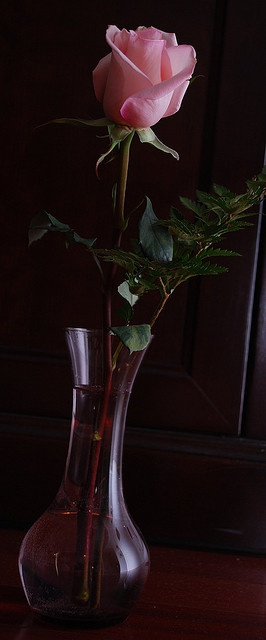Describe the objects in this image and their specific colors. I can see a vase in black, gray, maroon, and purple tones in this image. 